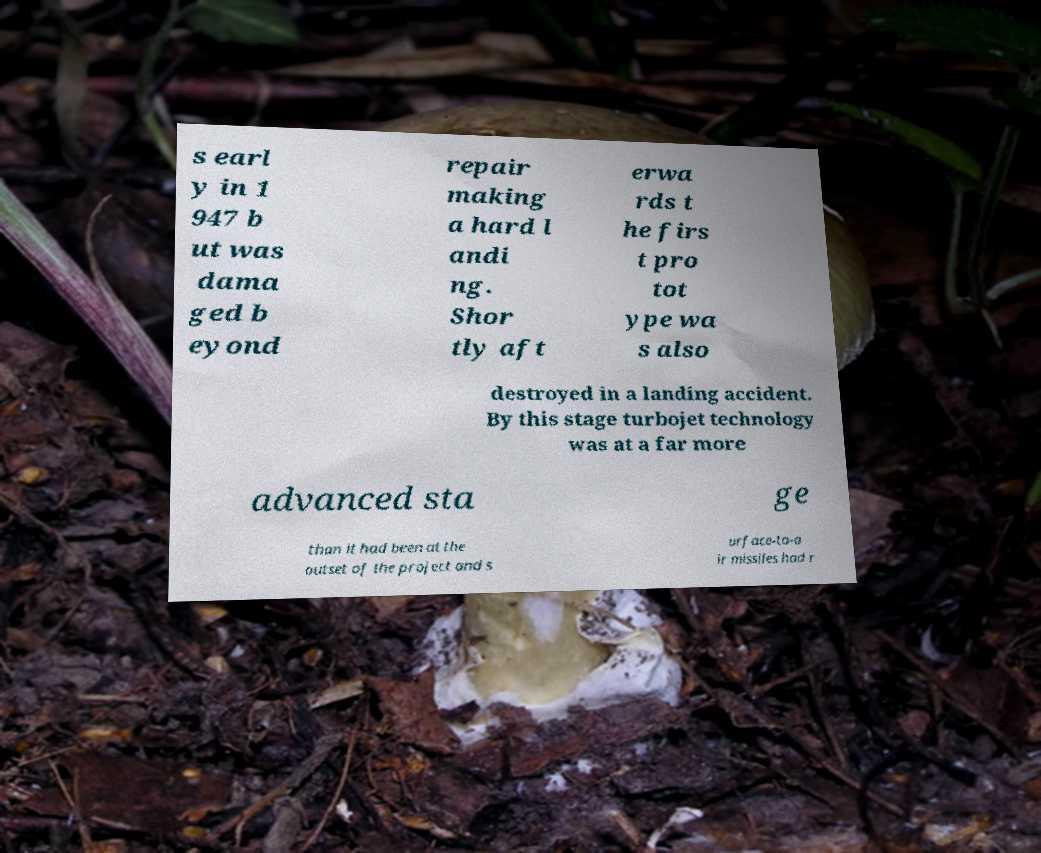Can you accurately transcribe the text from the provided image for me? s earl y in 1 947 b ut was dama ged b eyond repair making a hard l andi ng. Shor tly aft erwa rds t he firs t pro tot ype wa s also destroyed in a landing accident. By this stage turbojet technology was at a far more advanced sta ge than it had been at the outset of the project and s urface-to-a ir missiles had r 